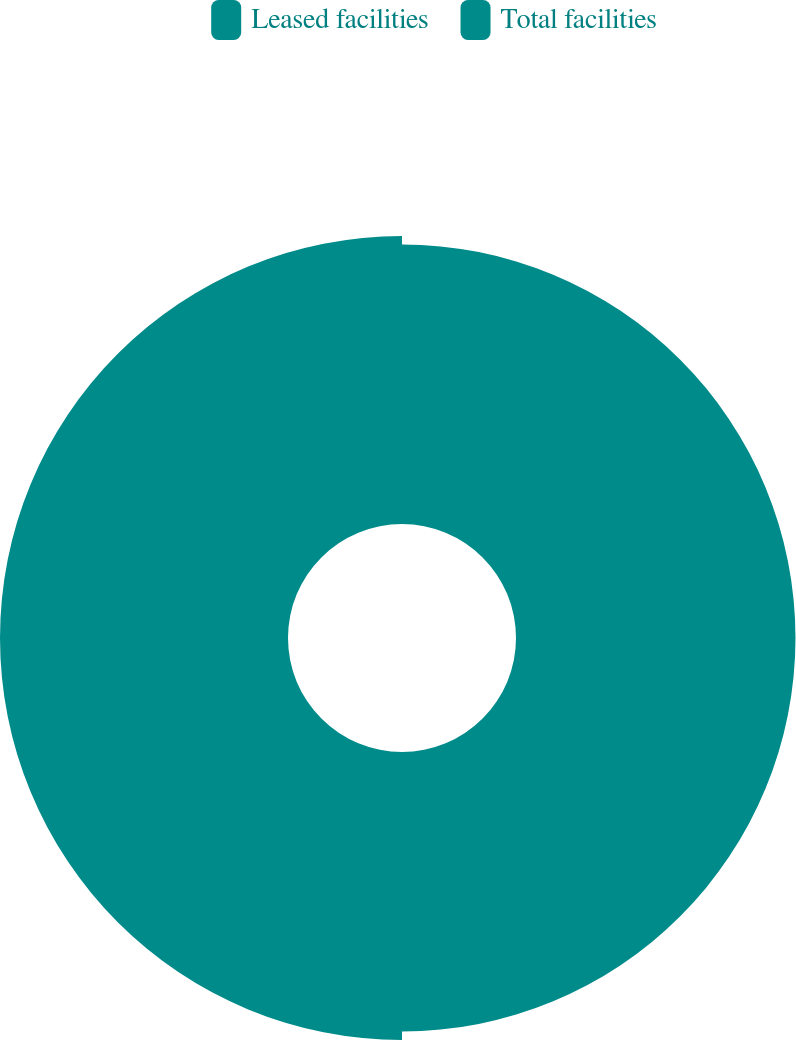Convert chart. <chart><loc_0><loc_0><loc_500><loc_500><pie_chart><fcel>Leased facilities<fcel>Total facilities<nl><fcel>49.25%<fcel>50.75%<nl></chart> 